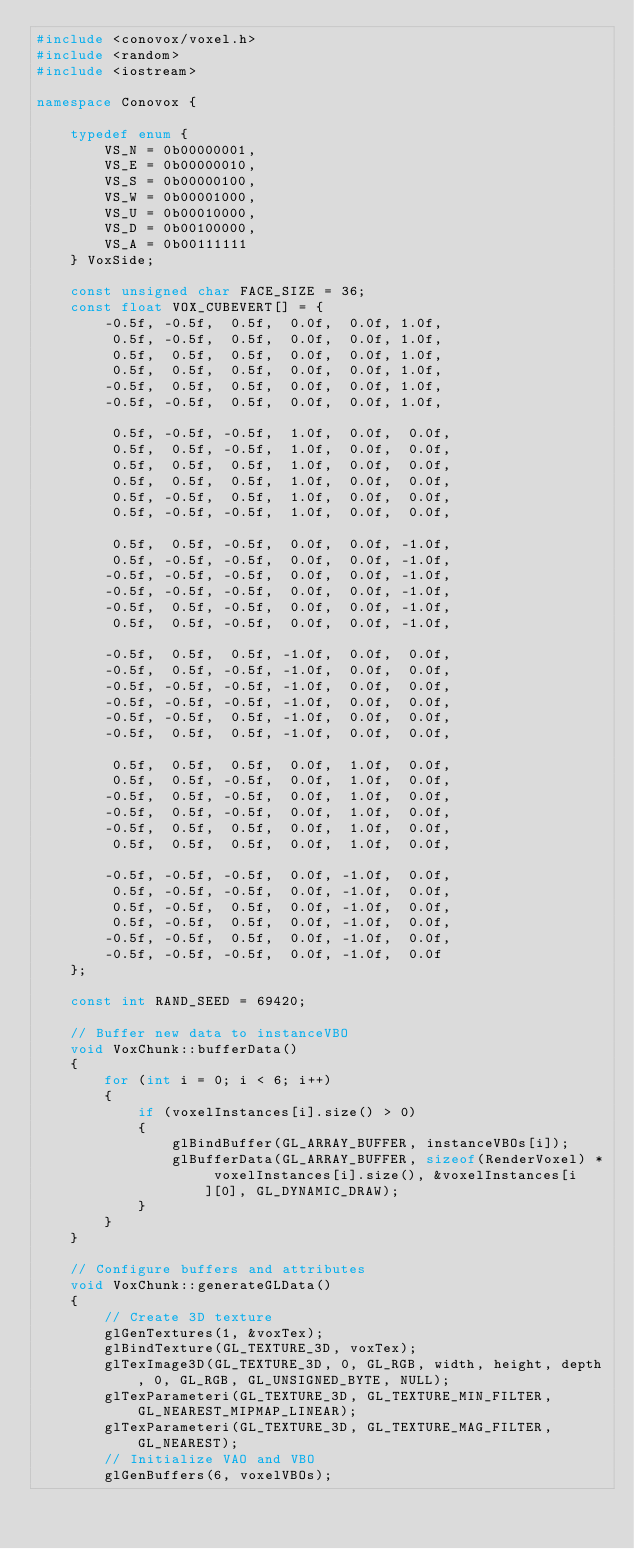<code> <loc_0><loc_0><loc_500><loc_500><_C++_>#include <conovox/voxel.h>
#include <random>
#include <iostream>

namespace Conovox {

    typedef enum {
        VS_N = 0b00000001,
        VS_E = 0b00000010,
        VS_S = 0b00000100,
        VS_W = 0b00001000,
        VS_U = 0b00010000,
        VS_D = 0b00100000,
        VS_A = 0b00111111
    } VoxSide;

    const unsigned char FACE_SIZE = 36;
    const float VOX_CUBEVERT[] = {
        -0.5f, -0.5f,  0.5f,  0.0f,  0.0f, 1.0f,
         0.5f, -0.5f,  0.5f,  0.0f,  0.0f, 1.0f,
         0.5f,  0.5f,  0.5f,  0.0f,  0.0f, 1.0f,
         0.5f,  0.5f,  0.5f,  0.0f,  0.0f, 1.0f,
        -0.5f,  0.5f,  0.5f,  0.0f,  0.0f, 1.0f,
        -0.5f, -0.5f,  0.5f,  0.0f,  0.0f, 1.0f,

         0.5f, -0.5f, -0.5f,  1.0f,  0.0f,  0.0f,
         0.5f,  0.5f, -0.5f,  1.0f,  0.0f,  0.0f,
         0.5f,  0.5f,  0.5f,  1.0f,  0.0f,  0.0f,
         0.5f,  0.5f,  0.5f,  1.0f,  0.0f,  0.0f,
         0.5f, -0.5f,  0.5f,  1.0f,  0.0f,  0.0f,
         0.5f, -0.5f, -0.5f,  1.0f,  0.0f,  0.0f,

         0.5f,  0.5f, -0.5f,  0.0f,  0.0f, -1.0f,
         0.5f, -0.5f, -0.5f,  0.0f,  0.0f, -1.0f,
        -0.5f, -0.5f, -0.5f,  0.0f,  0.0f, -1.0f,
        -0.5f, -0.5f, -0.5f,  0.0f,  0.0f, -1.0f,
        -0.5f,  0.5f, -0.5f,  0.0f,  0.0f, -1.0f,
         0.5f,  0.5f, -0.5f,  0.0f,  0.0f, -1.0f,

        -0.5f,  0.5f,  0.5f, -1.0f,  0.0f,  0.0f,
        -0.5f,  0.5f, -0.5f, -1.0f,  0.0f,  0.0f,
        -0.5f, -0.5f, -0.5f, -1.0f,  0.0f,  0.0f,
        -0.5f, -0.5f, -0.5f, -1.0f,  0.0f,  0.0f,
        -0.5f, -0.5f,  0.5f, -1.0f,  0.0f,  0.0f,
        -0.5f,  0.5f,  0.5f, -1.0f,  0.0f,  0.0f,

         0.5f,  0.5f,  0.5f,  0.0f,  1.0f,  0.0f,
         0.5f,  0.5f, -0.5f,  0.0f,  1.0f,  0.0f,
        -0.5f,  0.5f, -0.5f,  0.0f,  1.0f,  0.0f,
        -0.5f,  0.5f, -0.5f,  0.0f,  1.0f,  0.0f,
        -0.5f,  0.5f,  0.5f,  0.0f,  1.0f,  0.0f,
         0.5f,  0.5f,  0.5f,  0.0f,  1.0f,  0.0f,

        -0.5f, -0.5f, -0.5f,  0.0f, -1.0f,  0.0f,
         0.5f, -0.5f, -0.5f,  0.0f, -1.0f,  0.0f,
         0.5f, -0.5f,  0.5f,  0.0f, -1.0f,  0.0f,
         0.5f, -0.5f,  0.5f,  0.0f, -1.0f,  0.0f,
        -0.5f, -0.5f,  0.5f,  0.0f, -1.0f,  0.0f,
        -0.5f, -0.5f, -0.5f,  0.0f, -1.0f,  0.0f    
    };

    const int RAND_SEED = 69420;

    // Buffer new data to instanceVBO
    void VoxChunk::bufferData()
    {
        for (int i = 0; i < 6; i++)
        {
            if (voxelInstances[i].size() > 0)
            {
                glBindBuffer(GL_ARRAY_BUFFER, instanceVBOs[i]);
                glBufferData(GL_ARRAY_BUFFER, sizeof(RenderVoxel) * voxelInstances[i].size(), &voxelInstances[i][0], GL_DYNAMIC_DRAW);
            }
        }
    }

    // Configure buffers and attributes
    void VoxChunk::generateGLData()
    {
        // Create 3D texture
        glGenTextures(1, &voxTex);
        glBindTexture(GL_TEXTURE_3D, voxTex);
        glTexImage3D(GL_TEXTURE_3D, 0, GL_RGB, width, height, depth, 0, GL_RGB, GL_UNSIGNED_BYTE, NULL);
        glTexParameteri(GL_TEXTURE_3D, GL_TEXTURE_MIN_FILTER, GL_NEAREST_MIPMAP_LINEAR);
        glTexParameteri(GL_TEXTURE_3D, GL_TEXTURE_MAG_FILTER, GL_NEAREST);
        // Initialize VAO and VBO
        glGenBuffers(6, voxelVBOs);</code> 